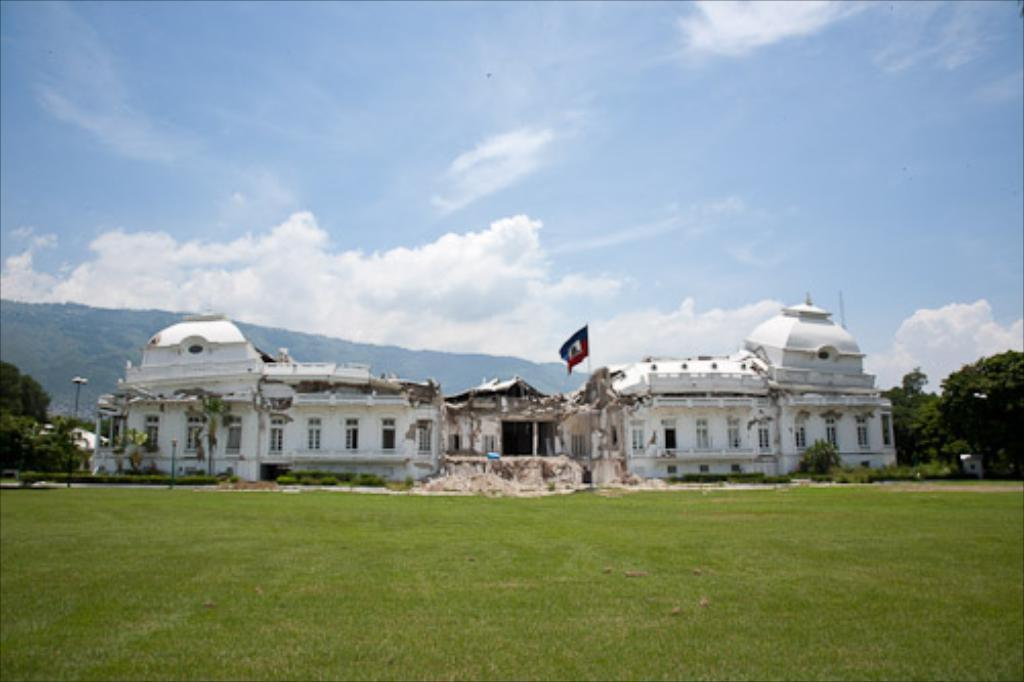What type of structure is present in the image? There is a building in the image. What feature can be seen on the building? The building has windows. What additional object is present in the image? There is a flag in the image. What type of natural elements can be seen in the image? There are trees, grass, and mountains in the image. What is visible in the background of the image? The sky is visible in the background of the image. What can be observed in the sky? There are clouds in the sky. What type of insurance policy is being discussed in the image? There is no indication of any insurance policy being discussed in the image. 